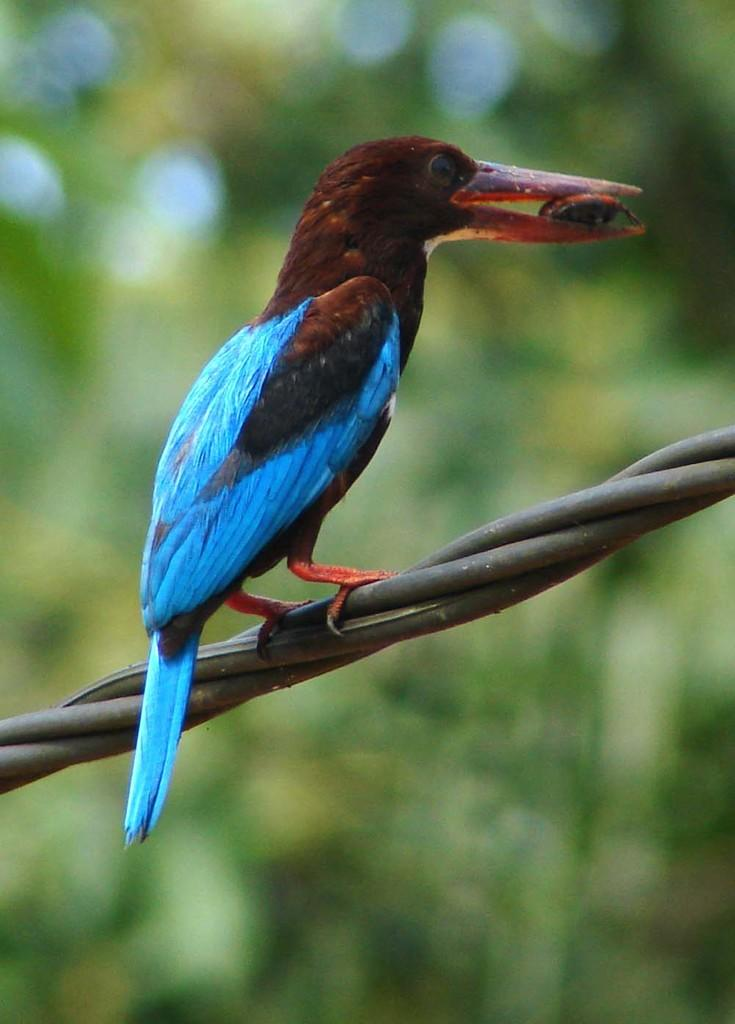What type of animal is in the image? There is a bird in the image. Where is the bird located? The bird is on a cable. Can you describe the background of the image? The background of the image is blurred. What type of door can be seen in the image? There is no door present in the image. 